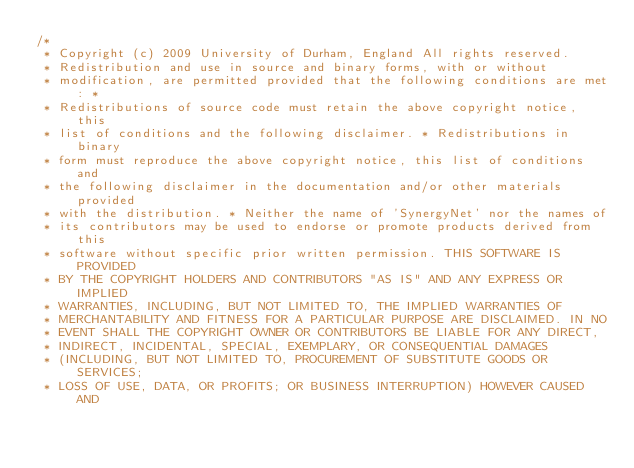<code> <loc_0><loc_0><loc_500><loc_500><_Java_>/*
 * Copyright (c) 2009 University of Durham, England All rights reserved.
 * Redistribution and use in source and binary forms, with or without
 * modification, are permitted provided that the following conditions are met: *
 * Redistributions of source code must retain the above copyright notice, this
 * list of conditions and the following disclaimer. * Redistributions in binary
 * form must reproduce the above copyright notice, this list of conditions and
 * the following disclaimer in the documentation and/or other materials provided
 * with the distribution. * Neither the name of 'SynergyNet' nor the names of
 * its contributors may be used to endorse or promote products derived from this
 * software without specific prior written permission. THIS SOFTWARE IS PROVIDED
 * BY THE COPYRIGHT HOLDERS AND CONTRIBUTORS "AS IS" AND ANY EXPRESS OR IMPLIED
 * WARRANTIES, INCLUDING, BUT NOT LIMITED TO, THE IMPLIED WARRANTIES OF
 * MERCHANTABILITY AND FITNESS FOR A PARTICULAR PURPOSE ARE DISCLAIMED. IN NO
 * EVENT SHALL THE COPYRIGHT OWNER OR CONTRIBUTORS BE LIABLE FOR ANY DIRECT,
 * INDIRECT, INCIDENTAL, SPECIAL, EXEMPLARY, OR CONSEQUENTIAL DAMAGES
 * (INCLUDING, BUT NOT LIMITED TO, PROCUREMENT OF SUBSTITUTE GOODS OR SERVICES;
 * LOSS OF USE, DATA, OR PROFITS; OR BUSINESS INTERRUPTION) HOWEVER CAUSED AND</code> 